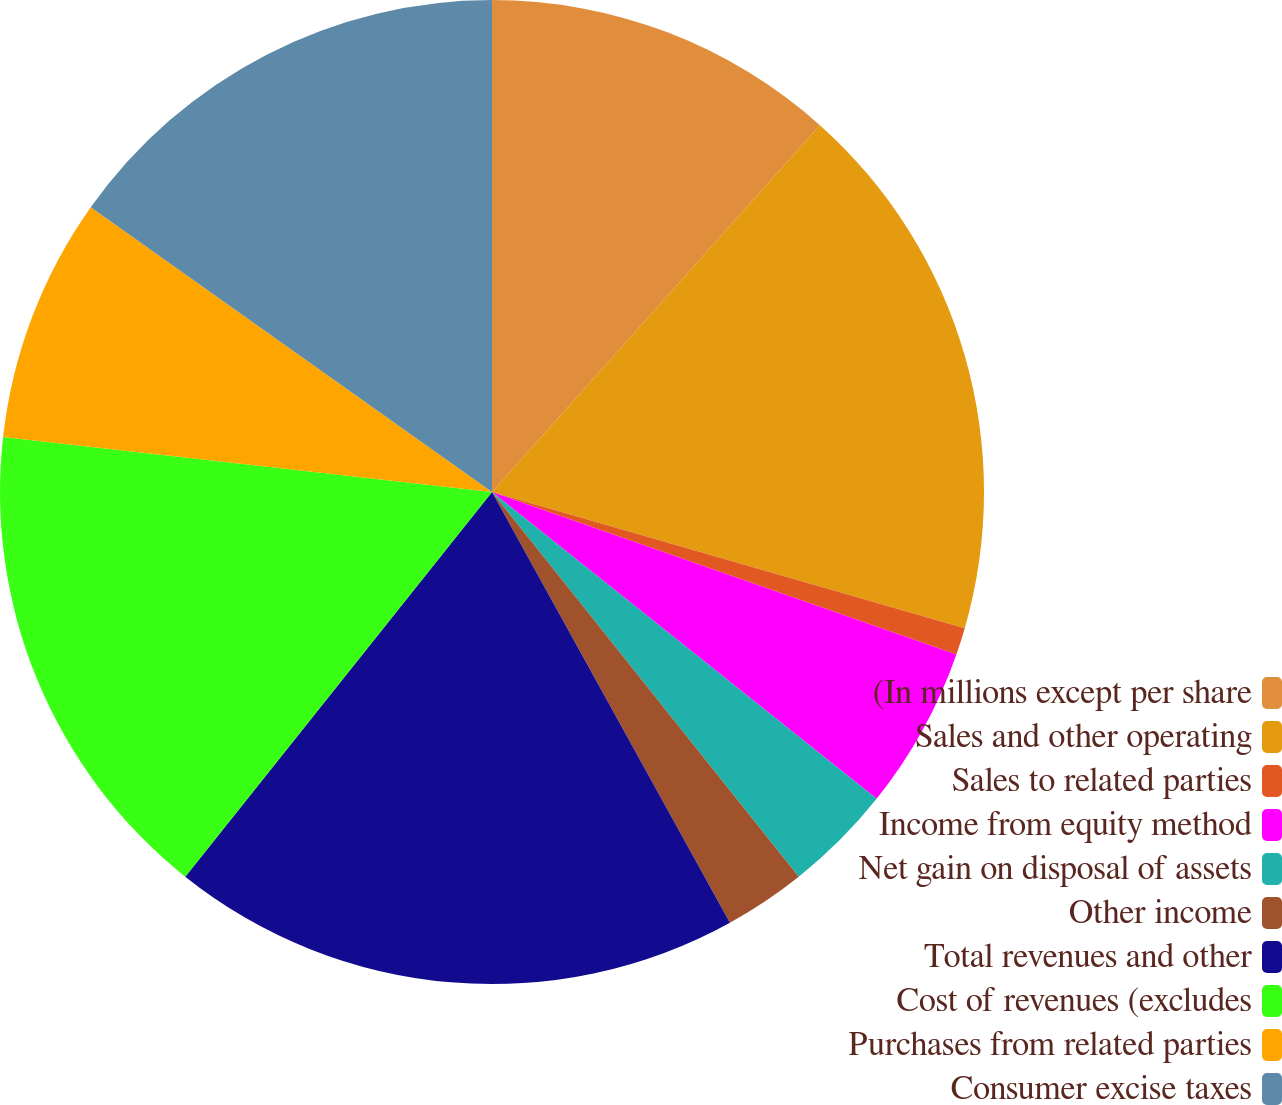Convert chart. <chart><loc_0><loc_0><loc_500><loc_500><pie_chart><fcel>(In millions except per share<fcel>Sales and other operating<fcel>Sales to related parties<fcel>Income from equity method<fcel>Net gain on disposal of assets<fcel>Other income<fcel>Total revenues and other<fcel>Cost of revenues (excludes<fcel>Purchases from related parties<fcel>Consumer excise taxes<nl><fcel>11.61%<fcel>17.86%<fcel>0.89%<fcel>5.36%<fcel>3.57%<fcel>2.68%<fcel>18.75%<fcel>16.07%<fcel>8.04%<fcel>15.18%<nl></chart> 